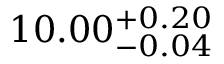<formula> <loc_0><loc_0><loc_500><loc_500>1 0 . 0 0 _ { - 0 . 0 4 } ^ { + 0 . 2 0 }</formula> 